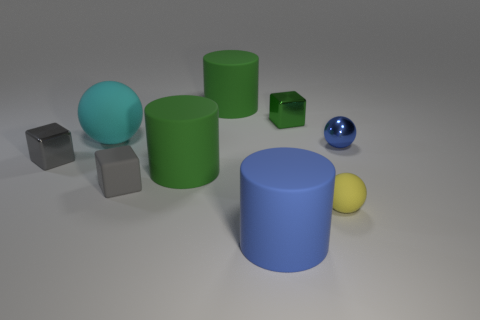Add 1 big green matte things. How many objects exist? 10 Subtract all cubes. How many objects are left? 6 Subtract all big blocks. Subtract all blue objects. How many objects are left? 7 Add 9 large blue matte objects. How many large blue matte objects are left? 10 Add 3 small gray metallic cubes. How many small gray metallic cubes exist? 4 Subtract 1 blue balls. How many objects are left? 8 